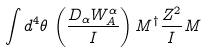Convert formula to latex. <formula><loc_0><loc_0><loc_500><loc_500>\int d ^ { 4 } \theta \, \left ( \frac { D _ { \alpha } W _ { A } ^ { \alpha } } { I } \right ) { M } ^ { \dagger } { \frac { Z ^ { 2 } } { I } } { M }</formula> 